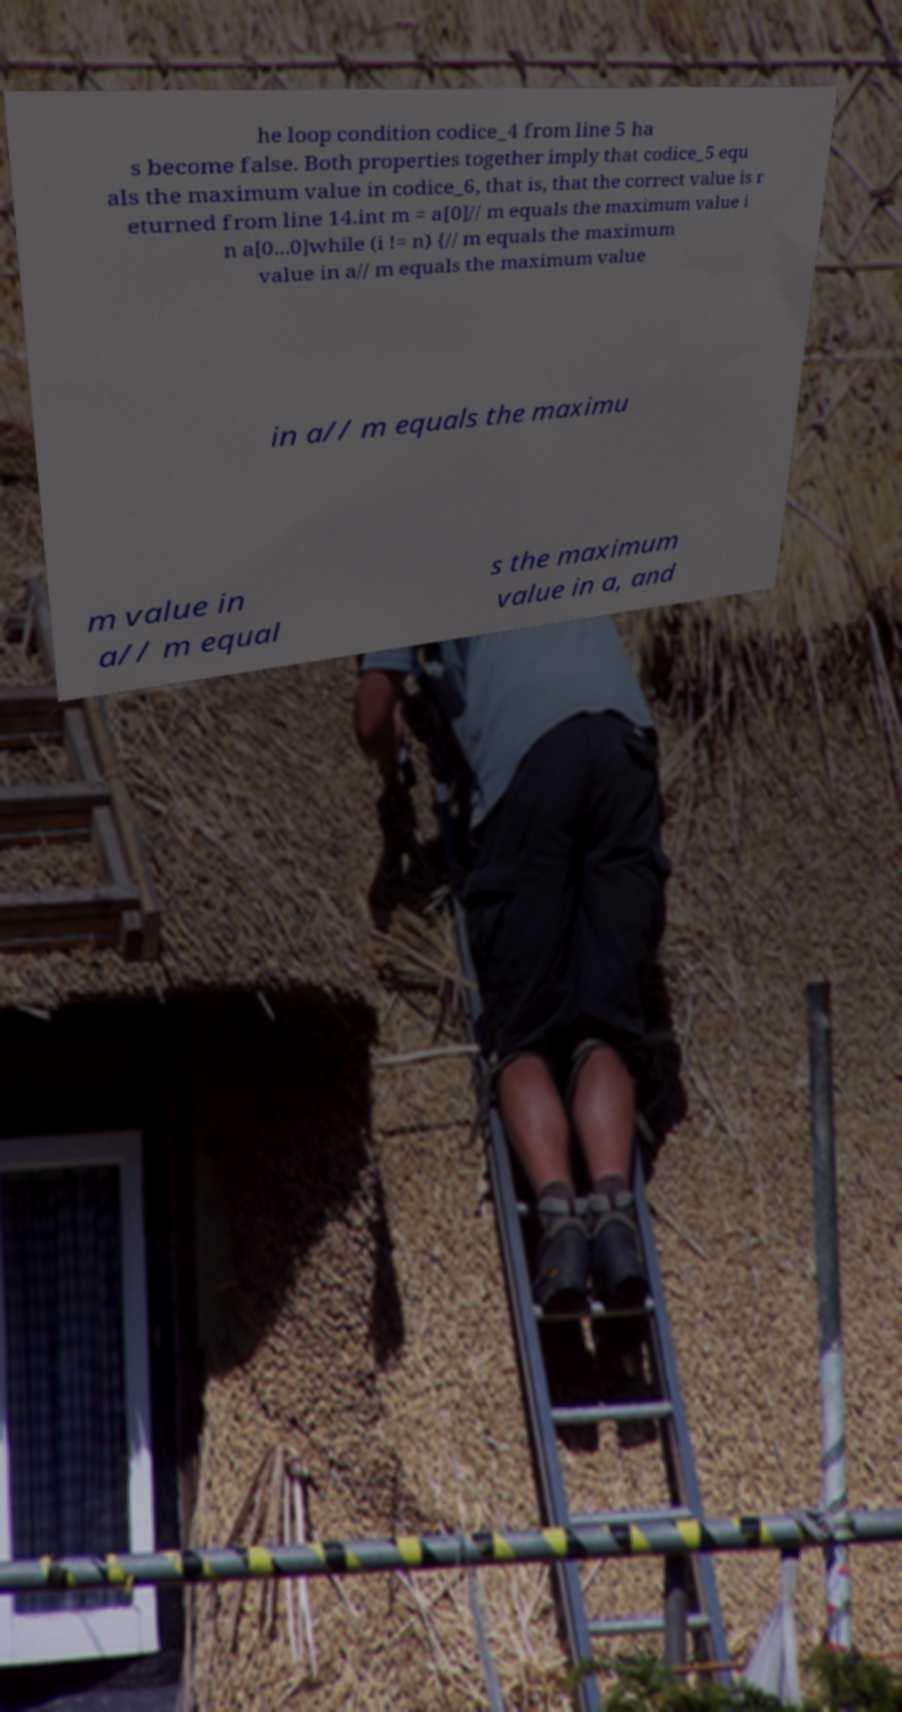I need the written content from this picture converted into text. Can you do that? he loop condition codice_4 from line 5 ha s become false. Both properties together imply that codice_5 equ als the maximum value in codice_6, that is, that the correct value is r eturned from line 14.int m = a[0]// m equals the maximum value i n a[0...0]while (i != n) {// m equals the maximum value in a// m equals the maximum value in a// m equals the maximu m value in a// m equal s the maximum value in a, and 